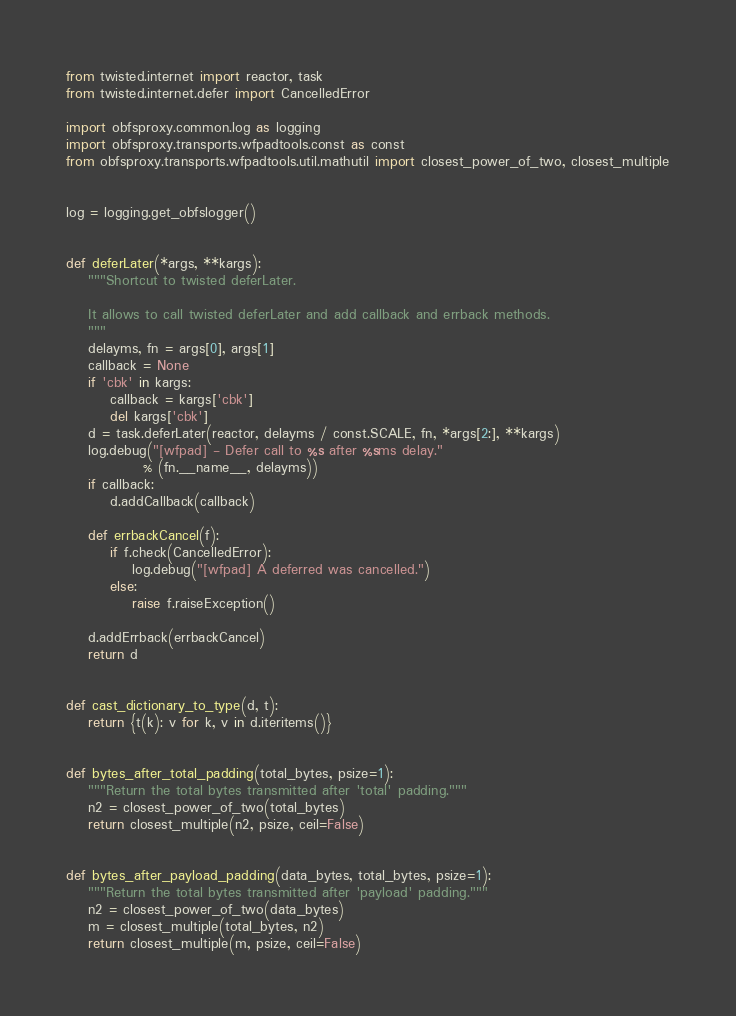<code> <loc_0><loc_0><loc_500><loc_500><_Python_>from twisted.internet import reactor, task
from twisted.internet.defer import CancelledError

import obfsproxy.common.log as logging
import obfsproxy.transports.wfpadtools.const as const
from obfsproxy.transports.wfpadtools.util.mathutil import closest_power_of_two, closest_multiple


log = logging.get_obfslogger()


def deferLater(*args, **kargs):
    """Shortcut to twisted deferLater.

    It allows to call twisted deferLater and add callback and errback methods.
    """
    delayms, fn = args[0], args[1]
    callback = None
    if 'cbk' in kargs:
        callback = kargs['cbk']
        del kargs['cbk']
    d = task.deferLater(reactor, delayms / const.SCALE, fn, *args[2:], **kargs)
    log.debug("[wfpad] - Defer call to %s after %sms delay."
              % (fn.__name__, delayms))
    if callback:
        d.addCallback(callback)

    def errbackCancel(f):
        if f.check(CancelledError):
            log.debug("[wfpad] A deferred was cancelled.")
        else:
            raise f.raiseException()

    d.addErrback(errbackCancel)
    return d


def cast_dictionary_to_type(d, t):
    return {t(k): v for k, v in d.iteritems()}


def bytes_after_total_padding(total_bytes, psize=1):
    """Return the total bytes transmitted after 'total' padding."""
    n2 = closest_power_of_two(total_bytes)
    return closest_multiple(n2, psize, ceil=False)


def bytes_after_payload_padding(data_bytes, total_bytes, psize=1):
    """Return the total bytes transmitted after 'payload' padding."""
    n2 = closest_power_of_two(data_bytes)
    m = closest_multiple(total_bytes, n2)
    return closest_multiple(m, psize, ceil=False)
</code> 